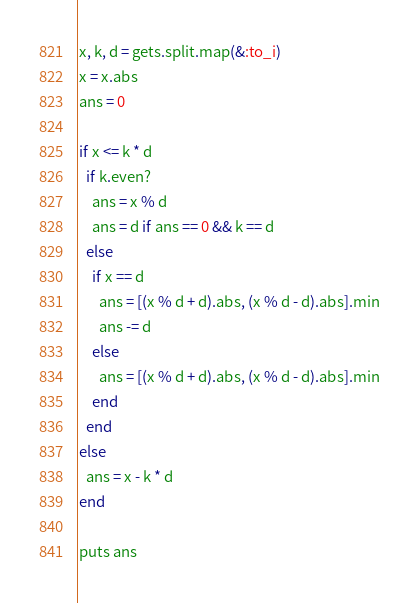<code> <loc_0><loc_0><loc_500><loc_500><_Ruby_>x, k, d = gets.split.map(&:to_i)
x = x.abs
ans = 0

if x <= k * d
  if k.even?
    ans = x % d
    ans = d if ans == 0 && k == d
  else
    if x == d
      ans = [(x % d + d).abs, (x % d - d).abs].min
      ans -= d
    else
      ans = [(x % d + d).abs, (x % d - d).abs].min
    end
  end
else
  ans = x - k * d
end

puts ans
</code> 